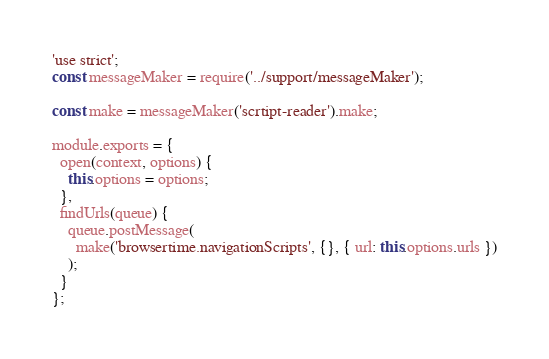Convert code to text. <code><loc_0><loc_0><loc_500><loc_500><_JavaScript_>'use strict';
const messageMaker = require('../support/messageMaker');

const make = messageMaker('scrtipt-reader').make;

module.exports = {
  open(context, options) {
    this.options = options;
  },
  findUrls(queue) {
    queue.postMessage(
      make('browsertime.navigationScripts', {}, { url: this.options.urls })
    );
  }
};
</code> 